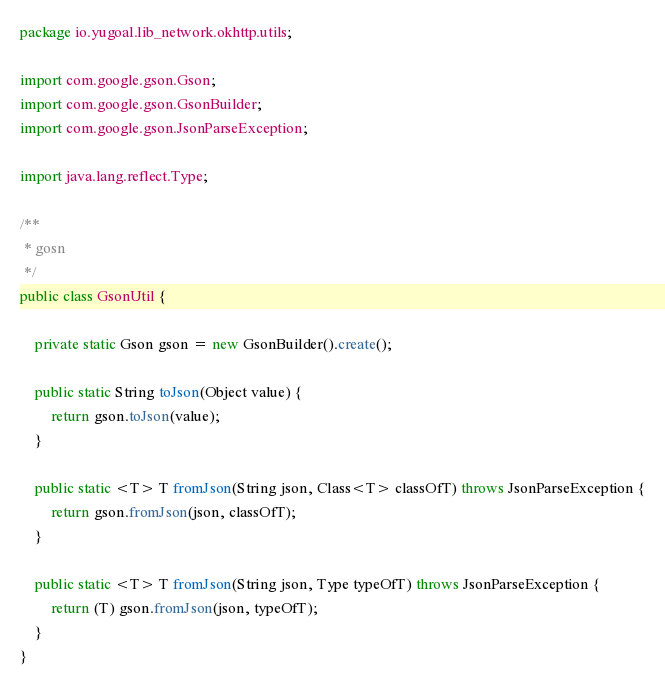<code> <loc_0><loc_0><loc_500><loc_500><_Java_>package io.yugoal.lib_network.okhttp.utils;

import com.google.gson.Gson;
import com.google.gson.GsonBuilder;
import com.google.gson.JsonParseException;

import java.lang.reflect.Type;

/**
 * gosn
 */
public class GsonUtil {

    private static Gson gson = new GsonBuilder().create();

    public static String toJson(Object value) {
        return gson.toJson(value);
    }

    public static <T> T fromJson(String json, Class<T> classOfT) throws JsonParseException {
        return gson.fromJson(json, classOfT);
    }

    public static <T> T fromJson(String json, Type typeOfT) throws JsonParseException {
        return (T) gson.fromJson(json, typeOfT);
    }
}</code> 